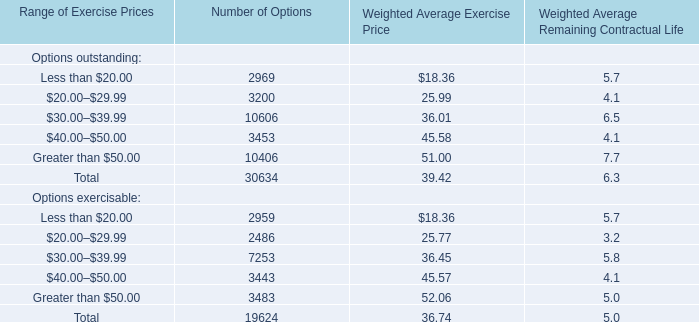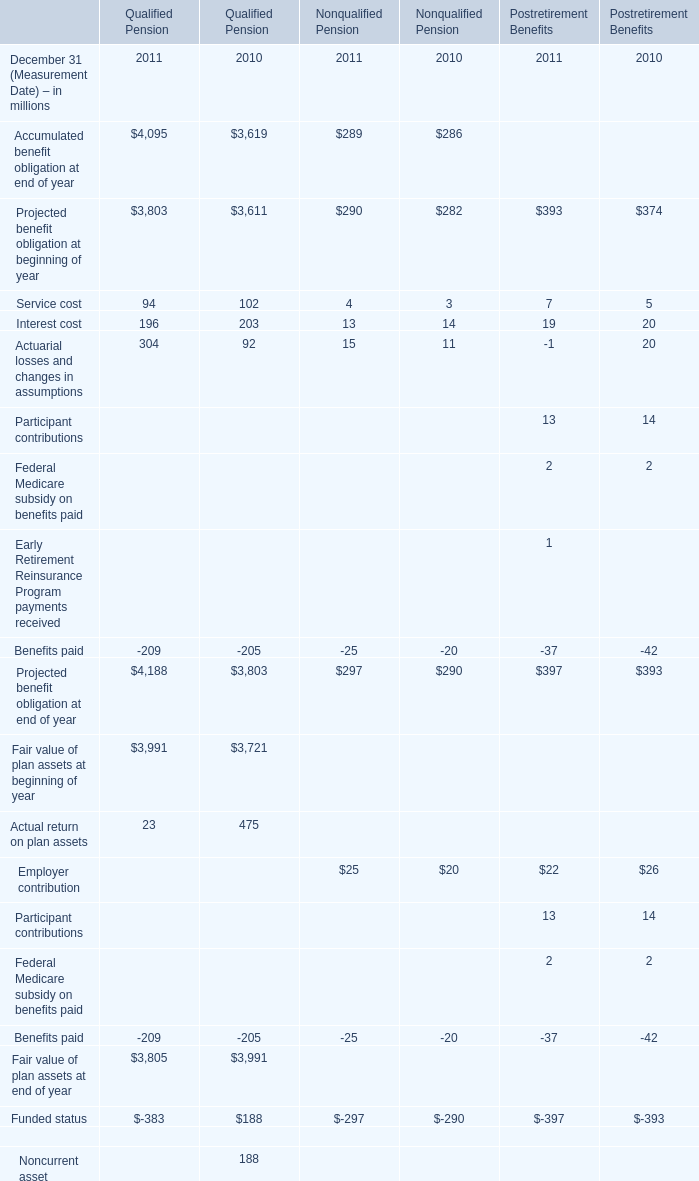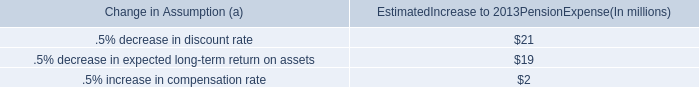by what percentage did the pension pretax expenses decrease from 2012 to 2013? 
Computations: (((89 - 73) / 89) * 100)
Answer: 17.97753. 